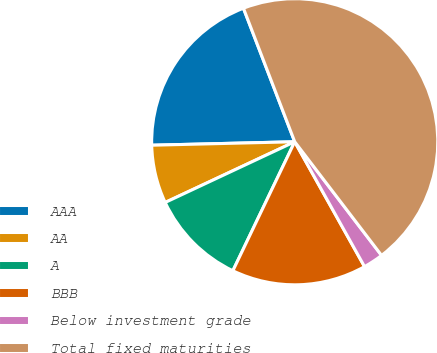Convert chart. <chart><loc_0><loc_0><loc_500><loc_500><pie_chart><fcel>AAA<fcel>AA<fcel>A<fcel>BBB<fcel>Below investment grade<fcel>Total fixed maturities<nl><fcel>19.55%<fcel>6.59%<fcel>10.91%<fcel>15.23%<fcel>2.27%<fcel>45.45%<nl></chart> 